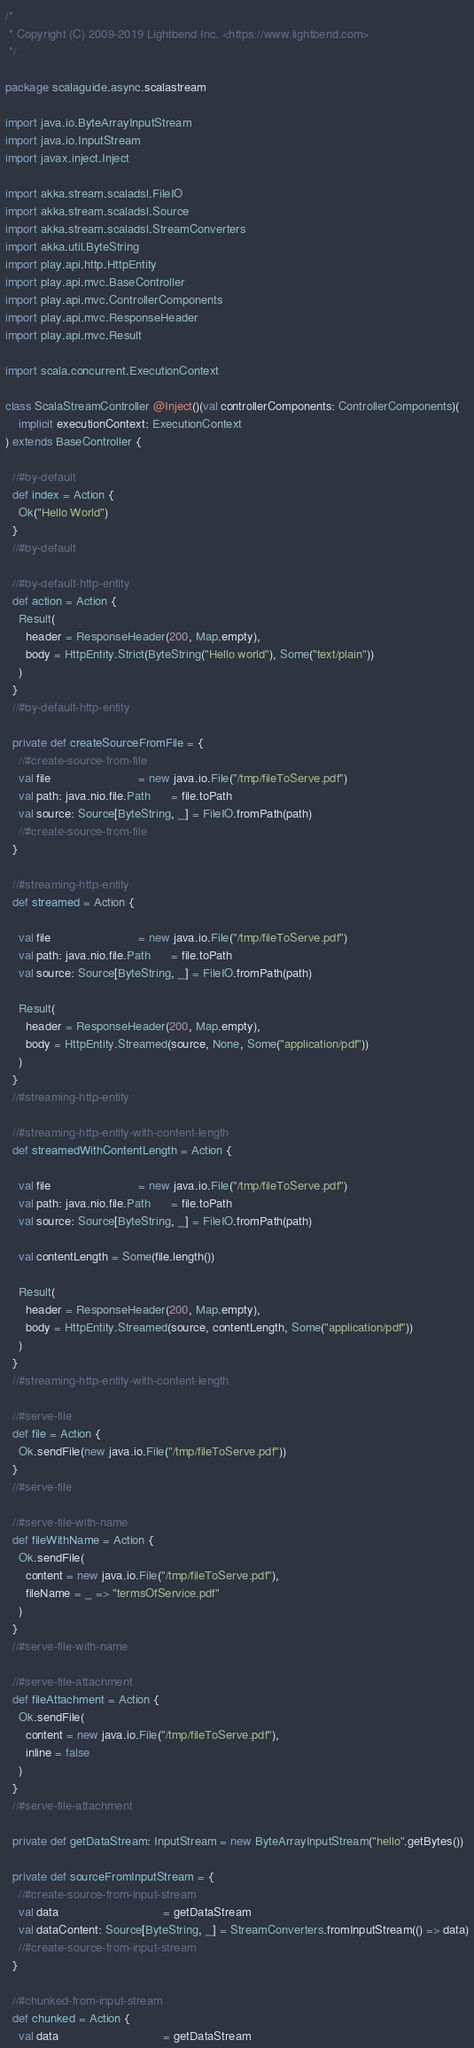Convert code to text. <code><loc_0><loc_0><loc_500><loc_500><_Scala_>/*
 * Copyright (C) 2009-2019 Lightbend Inc. <https://www.lightbend.com>
 */

package scalaguide.async.scalastream

import java.io.ByteArrayInputStream
import java.io.InputStream
import javax.inject.Inject

import akka.stream.scaladsl.FileIO
import akka.stream.scaladsl.Source
import akka.stream.scaladsl.StreamConverters
import akka.util.ByteString
import play.api.http.HttpEntity
import play.api.mvc.BaseController
import play.api.mvc.ControllerComponents
import play.api.mvc.ResponseHeader
import play.api.mvc.Result

import scala.concurrent.ExecutionContext

class ScalaStreamController @Inject()(val controllerComponents: ControllerComponents)(
    implicit executionContext: ExecutionContext
) extends BaseController {

  //#by-default
  def index = Action {
    Ok("Hello World")
  }
  //#by-default

  //#by-default-http-entity
  def action = Action {
    Result(
      header = ResponseHeader(200, Map.empty),
      body = HttpEntity.Strict(ByteString("Hello world"), Some("text/plain"))
    )
  }
  //#by-default-http-entity

  private def createSourceFromFile = {
    //#create-source-from-file
    val file                          = new java.io.File("/tmp/fileToServe.pdf")
    val path: java.nio.file.Path      = file.toPath
    val source: Source[ByteString, _] = FileIO.fromPath(path)
    //#create-source-from-file
  }

  //#streaming-http-entity
  def streamed = Action {

    val file                          = new java.io.File("/tmp/fileToServe.pdf")
    val path: java.nio.file.Path      = file.toPath
    val source: Source[ByteString, _] = FileIO.fromPath(path)

    Result(
      header = ResponseHeader(200, Map.empty),
      body = HttpEntity.Streamed(source, None, Some("application/pdf"))
    )
  }
  //#streaming-http-entity

  //#streaming-http-entity-with-content-length
  def streamedWithContentLength = Action {

    val file                          = new java.io.File("/tmp/fileToServe.pdf")
    val path: java.nio.file.Path      = file.toPath
    val source: Source[ByteString, _] = FileIO.fromPath(path)

    val contentLength = Some(file.length())

    Result(
      header = ResponseHeader(200, Map.empty),
      body = HttpEntity.Streamed(source, contentLength, Some("application/pdf"))
    )
  }
  //#streaming-http-entity-with-content-length

  //#serve-file
  def file = Action {
    Ok.sendFile(new java.io.File("/tmp/fileToServe.pdf"))
  }
  //#serve-file

  //#serve-file-with-name
  def fileWithName = Action {
    Ok.sendFile(
      content = new java.io.File("/tmp/fileToServe.pdf"),
      fileName = _ => "termsOfService.pdf"
    )
  }
  //#serve-file-with-name

  //#serve-file-attachment
  def fileAttachment = Action {
    Ok.sendFile(
      content = new java.io.File("/tmp/fileToServe.pdf"),
      inline = false
    )
  }
  //#serve-file-attachment

  private def getDataStream: InputStream = new ByteArrayInputStream("hello".getBytes())

  private def sourceFromInputStream = {
    //#create-source-from-input-stream
    val data                               = getDataStream
    val dataContent: Source[ByteString, _] = StreamConverters.fromInputStream(() => data)
    //#create-source-from-input-stream
  }

  //#chunked-from-input-stream
  def chunked = Action {
    val data                               = getDataStream</code> 